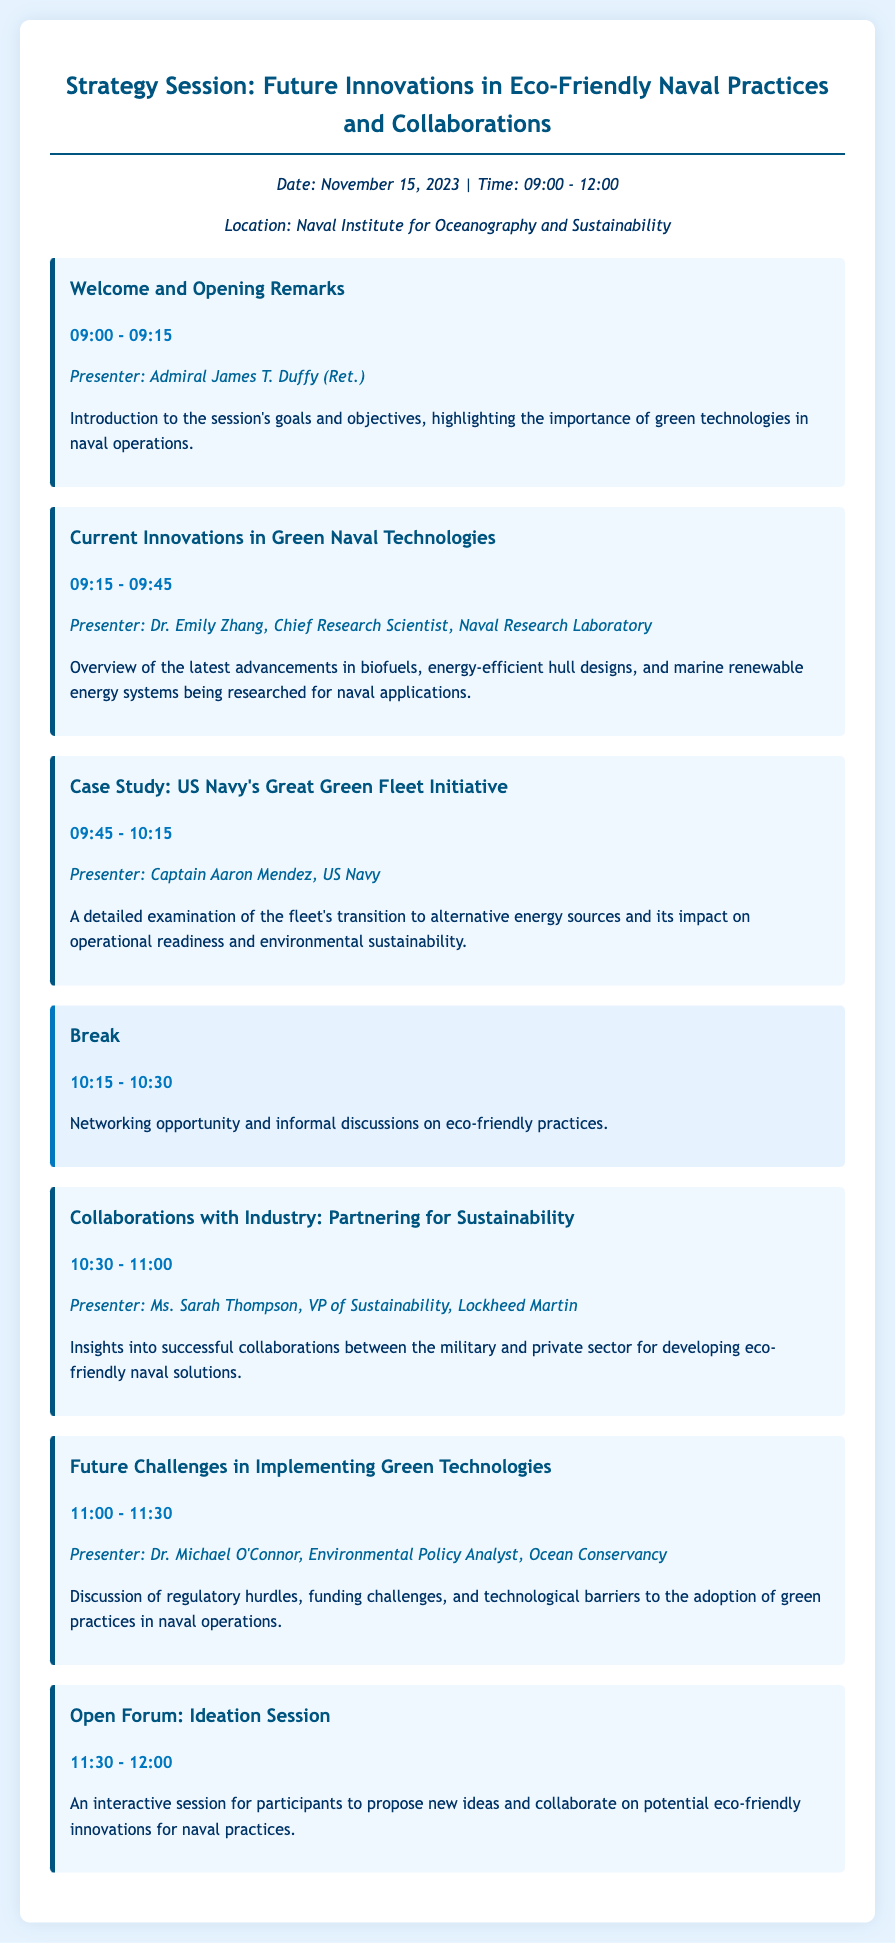What is the date of the strategy session? The document specifies the date of the session as November 15, 2023.
Answer: November 15, 2023 Who is presenting the opening remarks? The presenter of the opening remarks is Admiral James T. Duffy (Ret.).
Answer: Admiral James T. Duffy (Ret.) What time does the discussion on "Future Challenges in Implementing Green Technologies" begin? The session on future challenges starts at 11:00 am according to the agenda.
Answer: 11:00 Which company is represented by Ms. Sarah Thompson? Ms. Sarah Thompson is the VP of Sustainability at Lockheed Martin as mentioned in her details.
Answer: Lockheed Martin How long is the break scheduled for? The break is scheduled from 10:15 to 10:30, which is 15 minutes long.
Answer: 15 minutes What is the focus of the case study presented by Captain Aaron Mendez? The case study focuses on the US Navy's Great Green Fleet Initiative and its impact.
Answer: US Navy's Great Green Fleet Initiative What type of session is scheduled at 11:30? The agenda indicates that the session at 11:30 is an open forum focused on ideation.
Answer: Open Forum What is the main topic of Dr. Michael O'Connor's presentation? Dr. Michael O'Connor's presentation discusses challenges in implementing green technologies.
Answer: Challenges in implementing green technologies 